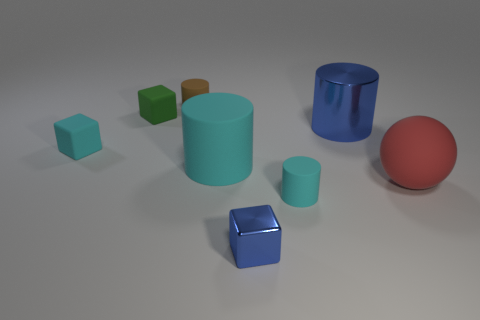There is a tiny block that is in front of the small green rubber thing and left of the brown rubber thing; what is its material?
Give a very brief answer. Rubber. Are there fewer large metal objects that are behind the tiny cyan rubber cube than metallic objects in front of the large blue metal cylinder?
Give a very brief answer. No. What number of other things are the same size as the blue metal block?
Your answer should be very brief. 4. What shape is the rubber thing right of the shiny thing behind the small cyan thing that is on the right side of the brown rubber cylinder?
Offer a terse response. Sphere. What number of cyan things are cylinders or small cylinders?
Keep it short and to the point. 2. How many tiny cyan rubber objects are behind the tiny cyan object on the right side of the small blue block?
Provide a short and direct response. 1. Is there any other thing that has the same color as the metallic cylinder?
Your response must be concise. Yes. What shape is the big cyan thing that is made of the same material as the sphere?
Provide a succinct answer. Cylinder. Is the color of the ball the same as the tiny metallic cube?
Provide a short and direct response. No. Is the cyan thing that is in front of the big rubber ball made of the same material as the tiny cube that is in front of the small cyan cylinder?
Provide a short and direct response. No. 